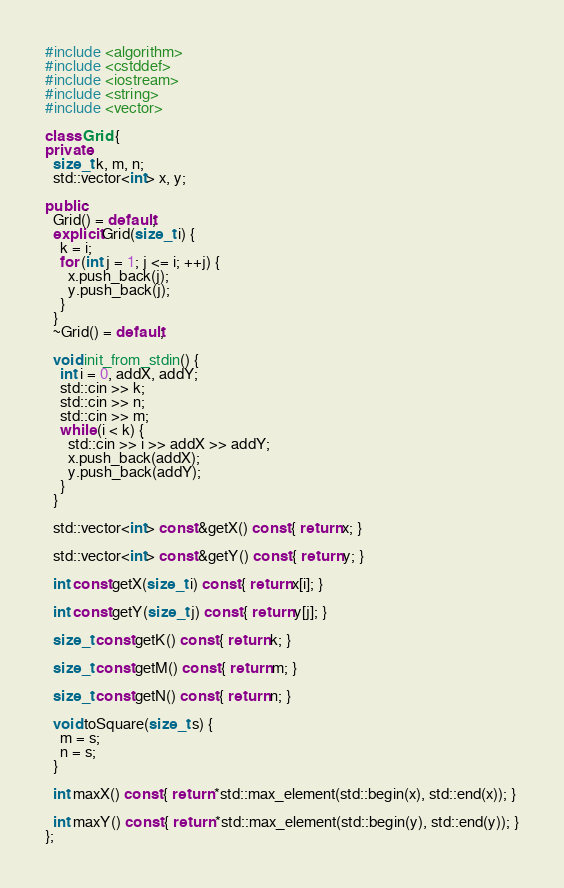Convert code to text. <code><loc_0><loc_0><loc_500><loc_500><_C++_>#include <algorithm>
#include <cstddef>
#include <iostream>
#include <string>
#include <vector>

class Grid {
private:
  size_t k, m, n;
  std::vector<int> x, y;

public:
  Grid() = default;
  explicit Grid(size_t i) {
    k = i;
    for (int j = 1; j <= i; ++j) {
      x.push_back(j);
      y.push_back(j);
    }
  }
  ~Grid() = default;

  void init_from_stdin() {
    int i = 0, addX, addY;
    std::cin >> k;
    std::cin >> n;
    std::cin >> m;
    while (i < k) {
      std::cin >> i >> addX >> addY;
      x.push_back(addX);
      y.push_back(addY);
    }
  }

  std::vector<int> const &getX() const { return x; }

  std::vector<int> const &getY() const { return y; }

  int const getX(size_t i) const { return x[i]; }

  int const getY(size_t j) const { return y[j]; }

  size_t const getK() const { return k; }

  size_t const getM() const { return m; }

  size_t const getN() const { return n; }

  void toSquare(size_t s) {
    m = s;
    n = s;
  }

  int maxX() const { return *std::max_element(std::begin(x), std::end(x)); }

  int maxY() const { return *std::max_element(std::begin(y), std::end(y)); }
};
</code> 